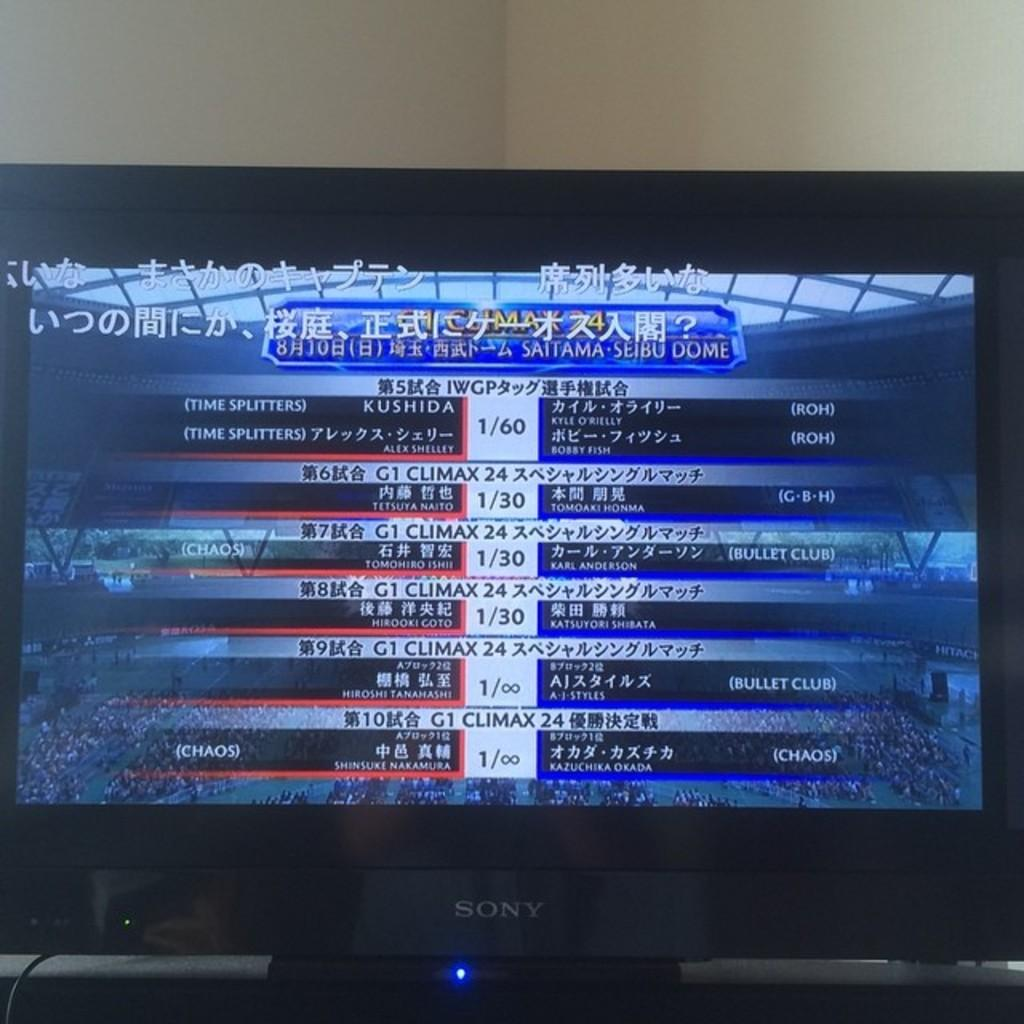<image>
Give a short and clear explanation of the subsequent image. the sony monitor has the scores from some competition showing on it 